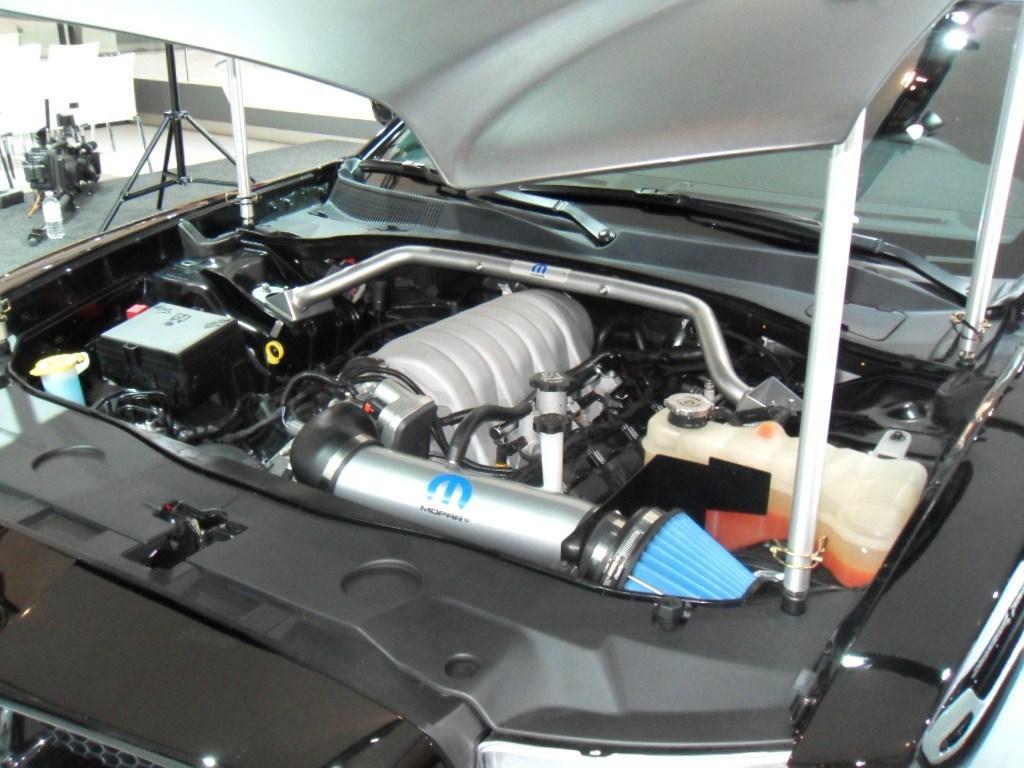Can you describe this image briefly? This image is an inside view of a vehicle. In the center of the image we can see engine, petrol tank. At the top left corner we can see stand, chairs, engine, bottle, floor and wall. 